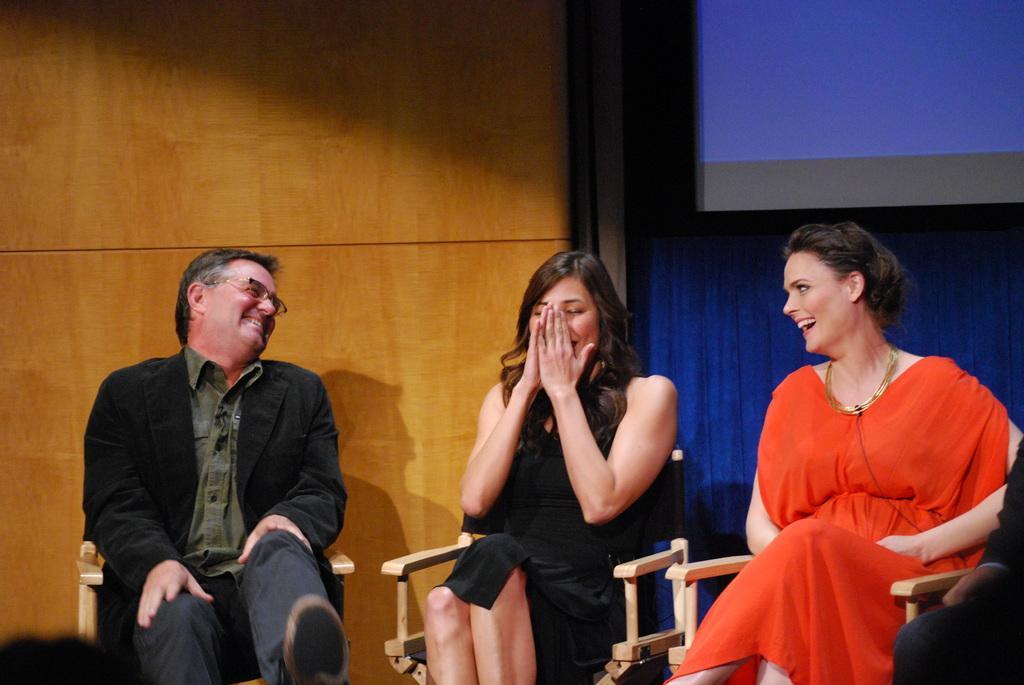Could you give a brief overview of what you see in this image? In this picture we can see there are three persons sitting on chairs. On the right side of the image, it looks like a hand of a person. Behind the people there is a wooden wall, curtain and a projector screen. 